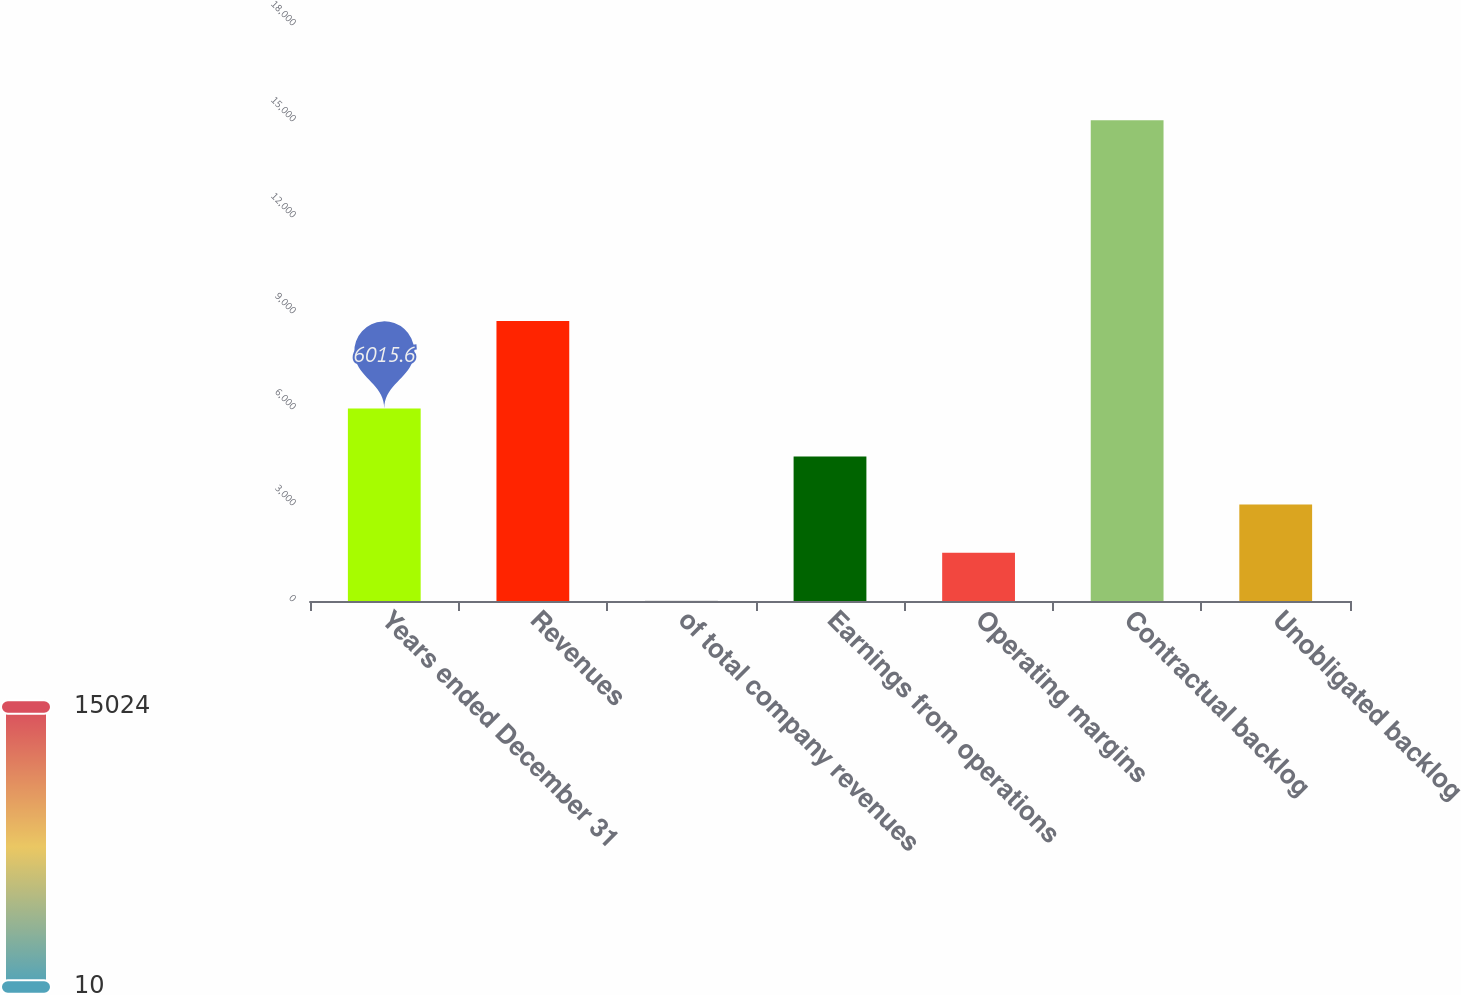Convert chart. <chart><loc_0><loc_0><loc_500><loc_500><bar_chart><fcel>Years ended December 31<fcel>Revenues<fcel>of total company revenues<fcel>Earnings from operations<fcel>Operating margins<fcel>Contractual backlog<fcel>Unobligated backlog<nl><fcel>6015.6<fcel>8749<fcel>10<fcel>4514.2<fcel>1511.4<fcel>15024<fcel>3012.8<nl></chart> 